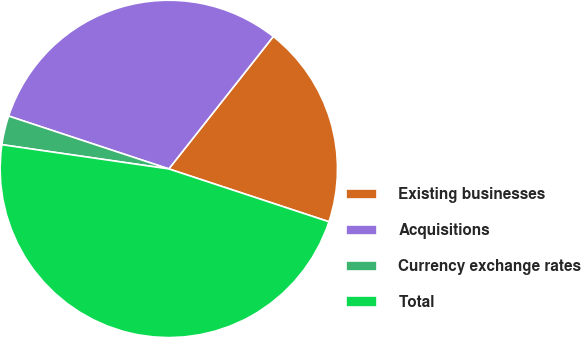<chart> <loc_0><loc_0><loc_500><loc_500><pie_chart><fcel>Existing businesses<fcel>Acquisitions<fcel>Currency exchange rates<fcel>Total<nl><fcel>19.44%<fcel>30.56%<fcel>2.78%<fcel>47.22%<nl></chart> 